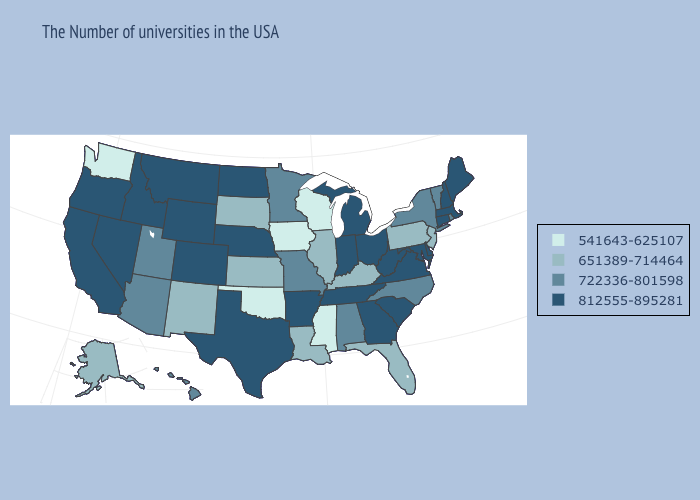Does Nevada have the highest value in the West?
Concise answer only. Yes. Among the states that border Kansas , which have the highest value?
Concise answer only. Nebraska, Colorado. Does Missouri have the highest value in the USA?
Concise answer only. No. Does Pennsylvania have the lowest value in the Northeast?
Write a very short answer. Yes. What is the value of New York?
Short answer required. 722336-801598. Which states have the lowest value in the USA?
Be succinct. Wisconsin, Mississippi, Iowa, Oklahoma, Washington. What is the value of Oklahoma?
Short answer required. 541643-625107. What is the value of Nebraska?
Give a very brief answer. 812555-895281. What is the value of Nebraska?
Be succinct. 812555-895281. Which states have the highest value in the USA?
Short answer required. Maine, Massachusetts, New Hampshire, Connecticut, Delaware, Maryland, Virginia, South Carolina, West Virginia, Ohio, Georgia, Michigan, Indiana, Tennessee, Arkansas, Nebraska, Texas, North Dakota, Wyoming, Colorado, Montana, Idaho, Nevada, California, Oregon. Among the states that border North Dakota , does South Dakota have the lowest value?
Keep it brief. Yes. What is the value of Florida?
Quick response, please. 651389-714464. Among the states that border Georgia , which have the lowest value?
Answer briefly. Florida. What is the value of West Virginia?
Be succinct. 812555-895281. What is the value of Indiana?
Keep it brief. 812555-895281. 